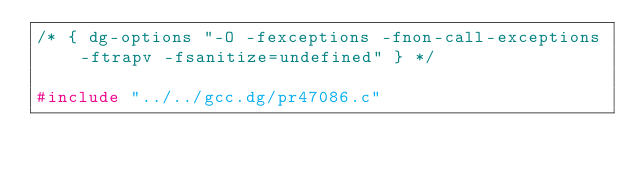Convert code to text. <code><loc_0><loc_0><loc_500><loc_500><_C_>/* { dg-options "-O -fexceptions -fnon-call-exceptions -ftrapv -fsanitize=undefined" } */

#include "../../gcc.dg/pr47086.c"
</code> 